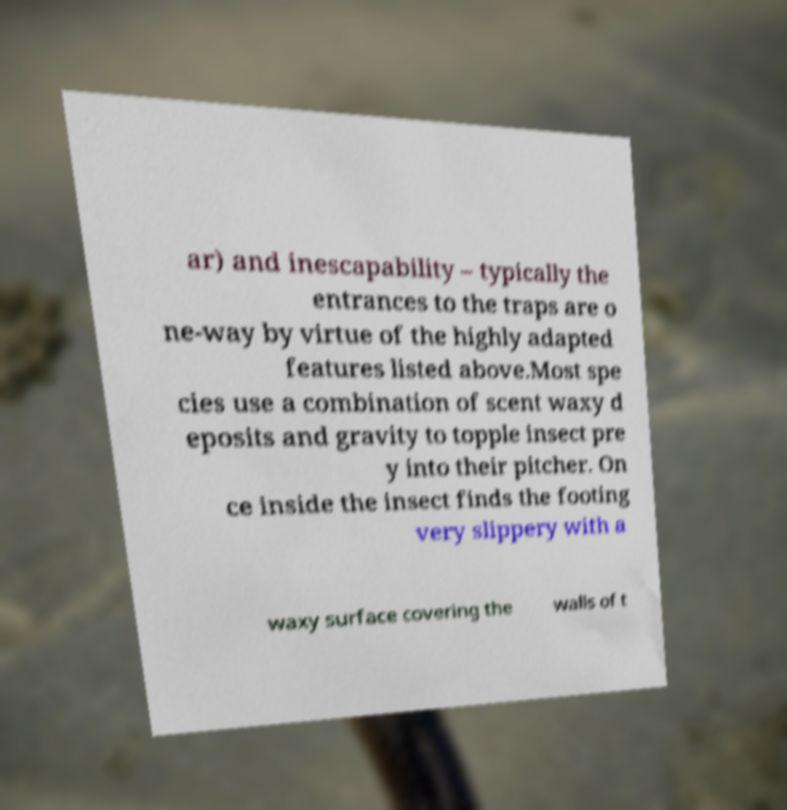There's text embedded in this image that I need extracted. Can you transcribe it verbatim? ar) and inescapability – typically the entrances to the traps are o ne-way by virtue of the highly adapted features listed above.Most spe cies use a combination of scent waxy d eposits and gravity to topple insect pre y into their pitcher. On ce inside the insect finds the footing very slippery with a waxy surface covering the walls of t 